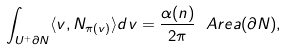<formula> <loc_0><loc_0><loc_500><loc_500>\int _ { U ^ { + } \partial N } \langle v , N _ { \pi ( v ) } \rangle d v = \frac { \alpha ( n ) } { 2 \pi } \ A r e a ( \partial N ) ,</formula> 